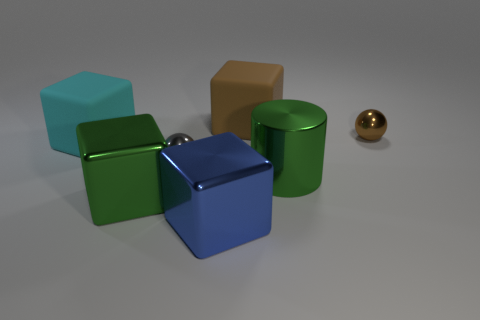How many objects are cubes that are left of the big blue metallic cube or metal things that are in front of the small gray metallic object?
Make the answer very short. 4. What material is the green block?
Ensure brevity in your answer.  Metal. How many other things are the same size as the blue metal object?
Give a very brief answer. 4. There is a ball behind the cyan matte object; what size is it?
Offer a very short reply. Small. There is a small ball in front of the small object that is on the right side of the green object behind the green metallic block; what is its material?
Your response must be concise. Metal. Is the shape of the large brown object the same as the big blue thing?
Ensure brevity in your answer.  Yes. How many rubber objects are large yellow objects or small brown balls?
Make the answer very short. 0. What number of large green shiny cubes are there?
Offer a very short reply. 1. There is another matte cube that is the same size as the cyan cube; what color is it?
Your answer should be compact. Brown. Is the brown matte thing the same size as the gray metallic object?
Keep it short and to the point. No. 